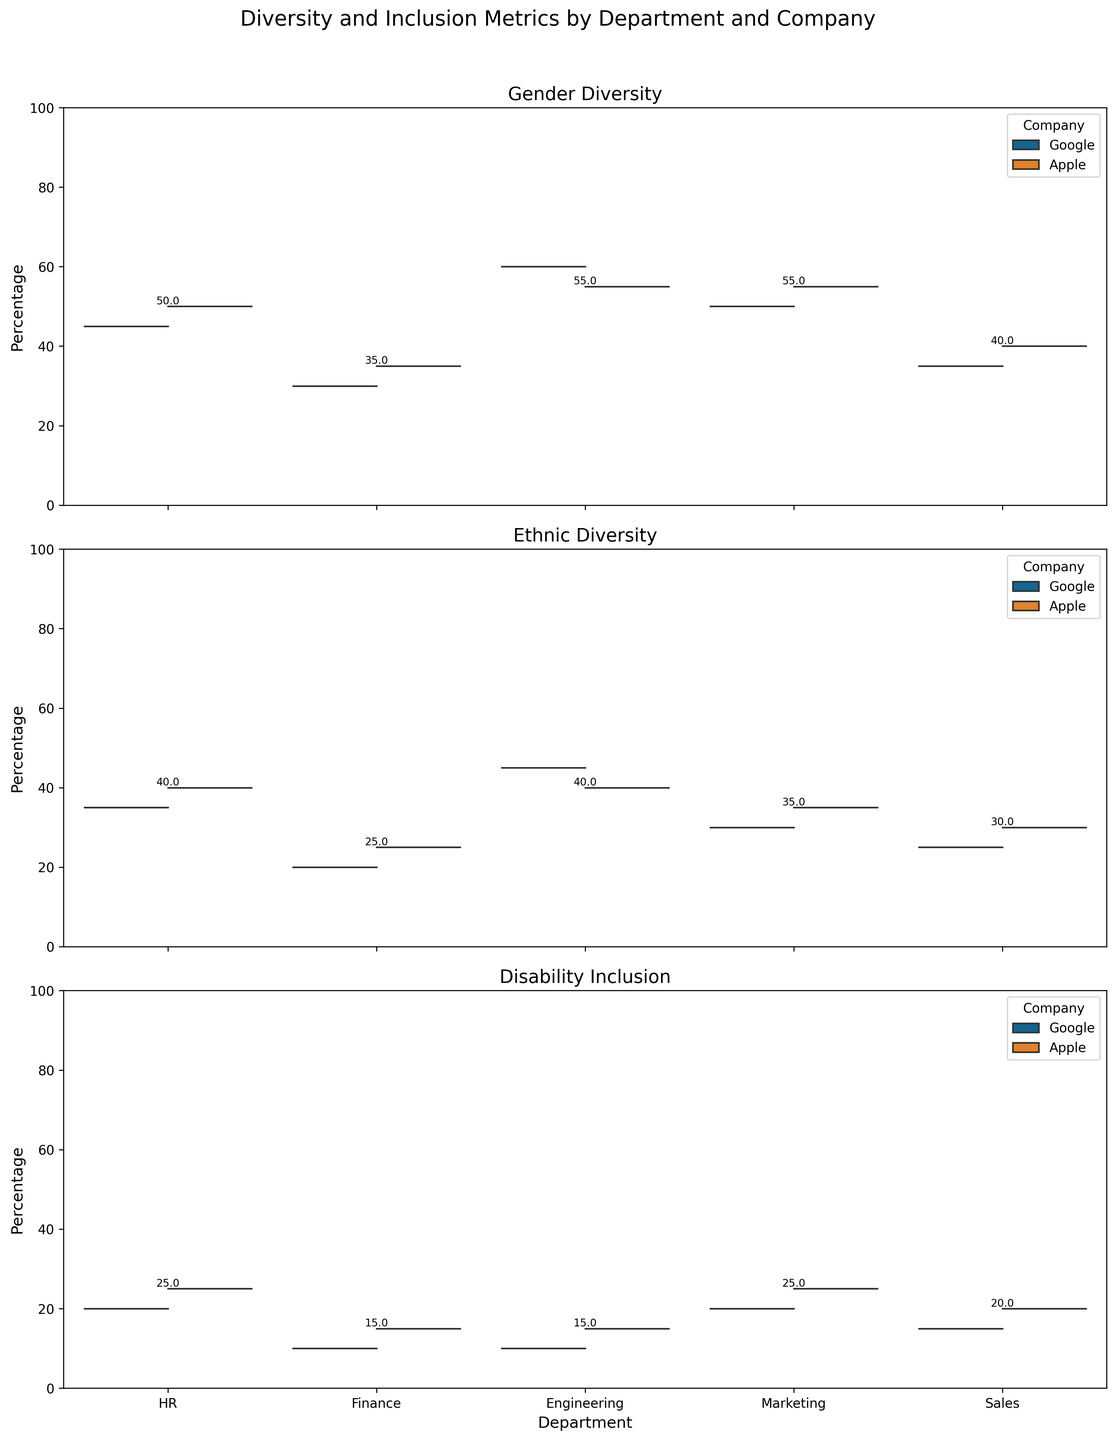What is the title of the figure? The title of the figure is located at the top and is generally the most prominent text element. It serves to summarize the content of the plot.
Answer: Diversity and Inclusion Metrics by Department and Company Which department shows the highest value for Gender Diversity in Google? In a Split Violin Chart, each section represents different departments, and the heights of the shaded areas indicate the value. The department with the highest peak represents the highest value.
Answer: Engineering What is the range of values for Ethnic Diversity in Apple's HR department? The range is the difference between the maximum and minimum values in the HR department's Ethnic Diversity violin plot for Apple, which can be observed from the plot shape.
Answer: 40 (since there's only one value) In which departments at Apple is the Gender Diversity percentage greater than 50%? By inspecting the split violin plots for Apple across all departments, we observe if the peak value for Gender Diversity is above 50%.
Answer: HR, Engineering, Marketing Which department has the lowest Disability Inclusion metrics for both companies combined? The department with the smallest peak height or density in the Disability Inclusion category, found by comparing the plots for both companies.
Answer: Finance Compare the Gender Diversity between Google and Apple in the Sales department. Which one has a higher value? Find the peaks for the Sales department in the Gender Diversity metric and compare them directly.
Answer: Apple How do the Ethnic Diversity metrics compare between Google's Marketing and Sales departments? Look at the respective violin plots for Ethnic Diversity in Marketing and Sales for Google and compare their peak values.
Answer: Marketing has a higher value What is the combined average of Disability Inclusion values across all departments for Apple? Sum the Disability Inclusion values for Apple across all departments and divide by the number of departments (5). Calculation: (25+15+15+25+20) / 5 = 20
Answer: 20 Which company has a higher average value for Gender Diversity across all departments? Calculate the mean of the Gender Diversity values for both companies and compare. For Google: (45+30+60+50+35)/5 = 44, for Apple: (50+35+55+55+40)/5 = 47
Answer: Apple Identify the department with the most significant difference in Ethnic Diversity between the two companies. Subtract the Ethnic Diversity values for Google from Apple for each department and find the maximum absolute difference. HR: 40-35=5, Finance: 25-20=5, Engineering: 40-45=-5, Marketing: 35-30=5, Sales: 30-25=5; all differences are 5.
Answer: All differences are equal at 5 